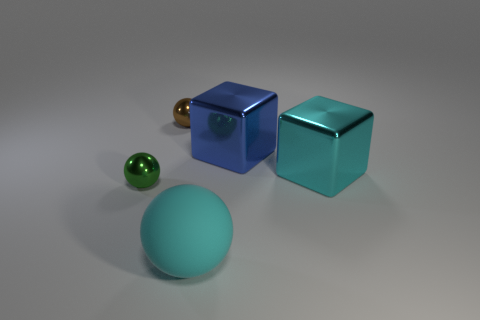There is a metal thing that is both in front of the blue metal cube and right of the rubber sphere; what color is it?
Provide a succinct answer. Cyan. Is there a big cyan metallic object that has the same shape as the blue object?
Make the answer very short. Yes. What is the large ball made of?
Keep it short and to the point. Rubber. There is a green thing; are there any matte balls right of it?
Offer a very short reply. Yes. Do the tiny brown object and the matte object have the same shape?
Provide a short and direct response. Yes. What number of other objects are the same size as the matte thing?
Your response must be concise. 2. How many things are tiny metallic balls that are to the right of the tiny green metallic ball or tiny green shiny things?
Your answer should be compact. 2. The large rubber sphere has what color?
Make the answer very short. Cyan. There is a large object that is in front of the large cyan metal object; what material is it?
Your answer should be very brief. Rubber. There is a large cyan matte thing; does it have the same shape as the cyan thing that is behind the large cyan ball?
Your response must be concise. No. 